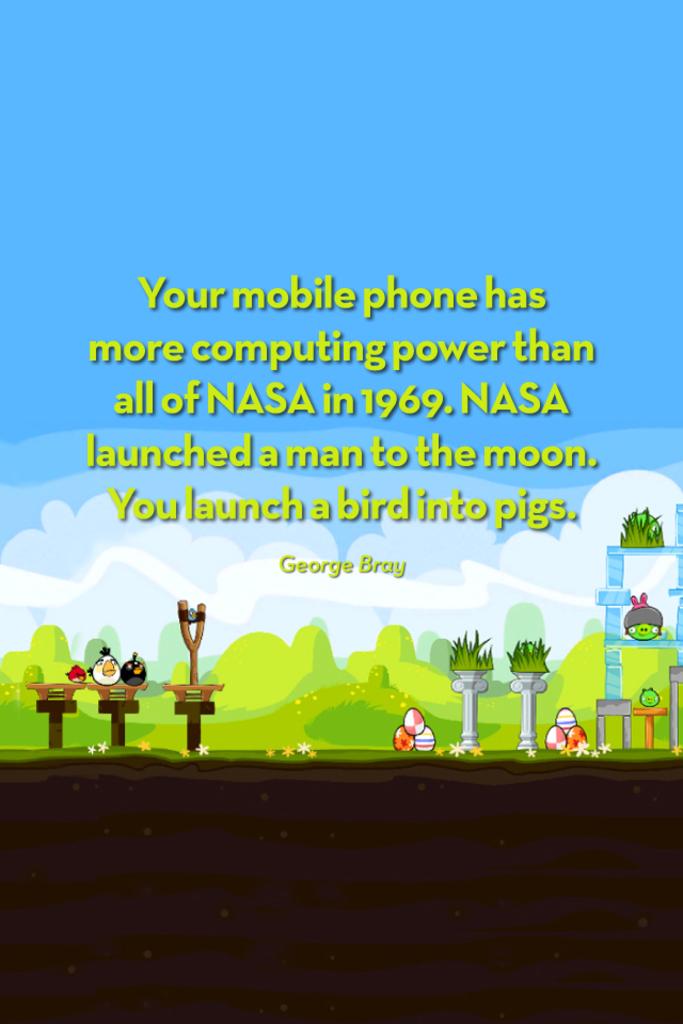Who is the author of this quote?
Your answer should be very brief. George bray. What is the year?
Keep it short and to the point. 1969. 